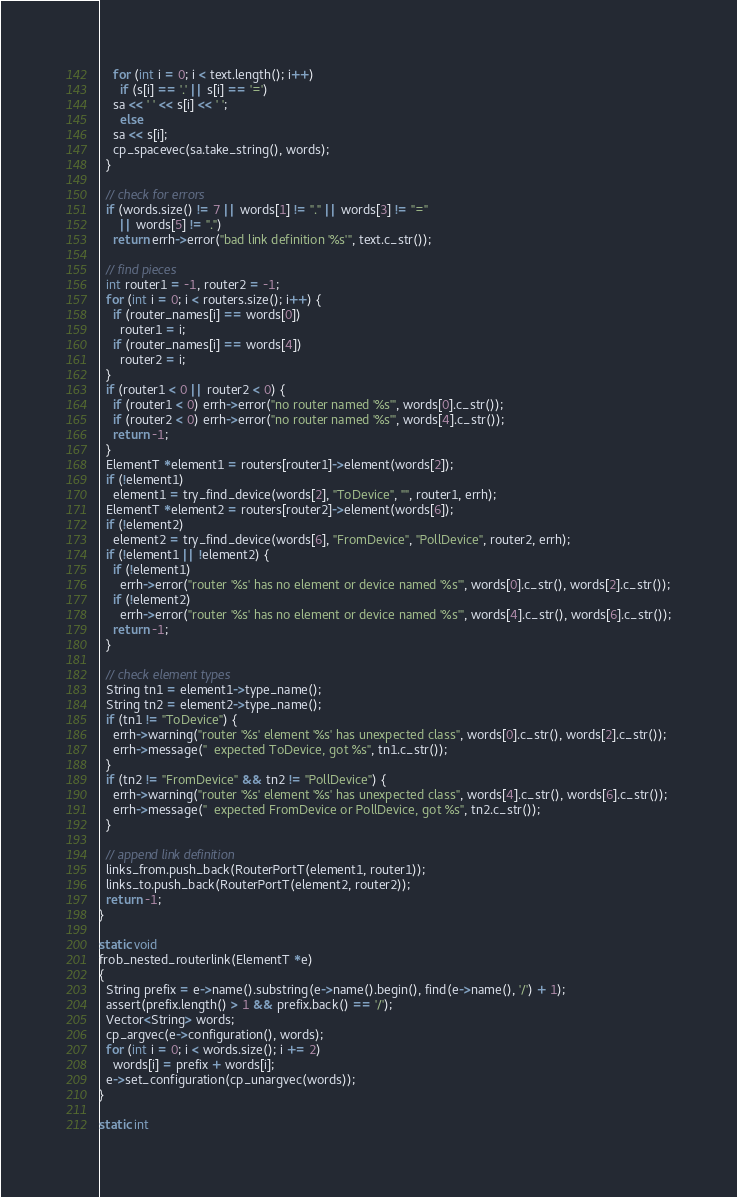<code> <loc_0><loc_0><loc_500><loc_500><_C++_>    for (int i = 0; i < text.length(); i++)
      if (s[i] == '.' || s[i] == '=')
	sa << ' ' << s[i] << ' ';
      else
	sa << s[i];
    cp_spacevec(sa.take_string(), words);
  }

  // check for errors
  if (words.size() != 7 || words[1] != "." || words[3] != "="
      || words[5] != ".")
    return errh->error("bad link definition '%s'", text.c_str());

  // find pieces
  int router1 = -1, router2 = -1;
  for (int i = 0; i < routers.size(); i++) {
    if (router_names[i] == words[0])
      router1 = i;
    if (router_names[i] == words[4])
      router2 = i;
  }
  if (router1 < 0 || router2 < 0) {
    if (router1 < 0) errh->error("no router named '%s'", words[0].c_str());
    if (router2 < 0) errh->error("no router named '%s'", words[4].c_str());
    return -1;
  }
  ElementT *element1 = routers[router1]->element(words[2]);
  if (!element1)
    element1 = try_find_device(words[2], "ToDevice", "", router1, errh);
  ElementT *element2 = routers[router2]->element(words[6]);
  if (!element2)
    element2 = try_find_device(words[6], "FromDevice", "PollDevice", router2, errh);
  if (!element1 || !element2) {
    if (!element1)
      errh->error("router '%s' has no element or device named '%s'", words[0].c_str(), words[2].c_str());
    if (!element2)
      errh->error("router '%s' has no element or device named '%s'", words[4].c_str(), words[6].c_str());
    return -1;
  }

  // check element types
  String tn1 = element1->type_name();
  String tn2 = element2->type_name();
  if (tn1 != "ToDevice") {
    errh->warning("router '%s' element '%s' has unexpected class", words[0].c_str(), words[2].c_str());
    errh->message("  expected ToDevice, got %s", tn1.c_str());
  }
  if (tn2 != "FromDevice" && tn2 != "PollDevice") {
    errh->warning("router '%s' element '%s' has unexpected class", words[4].c_str(), words[6].c_str());
    errh->message("  expected FromDevice or PollDevice, got %s", tn2.c_str());
  }

  // append link definition
  links_from.push_back(RouterPortT(element1, router1));
  links_to.push_back(RouterPortT(element2, router2));
  return -1;
}

static void
frob_nested_routerlink(ElementT *e)
{
  String prefix = e->name().substring(e->name().begin(), find(e->name(), '/') + 1);
  assert(prefix.length() > 1 && prefix.back() == '/');
  Vector<String> words;
  cp_argvec(e->configuration(), words);
  for (int i = 0; i < words.size(); i += 2)
    words[i] = prefix + words[i];
  e->set_configuration(cp_unargvec(words));
}

static int</code> 